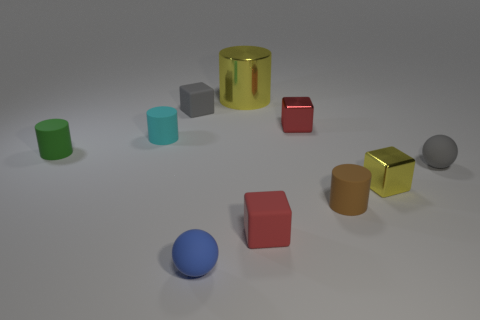What might be the significance of the different geometric shapes present? The diversity of shapes - cylinders, cubes, and spheres - could represent variety in uniformity. This assortment might suggest a theme of individuality coexisting within a structured environment, or it might simply be an exploration of geometric forms and how they interact with light and shadow. 